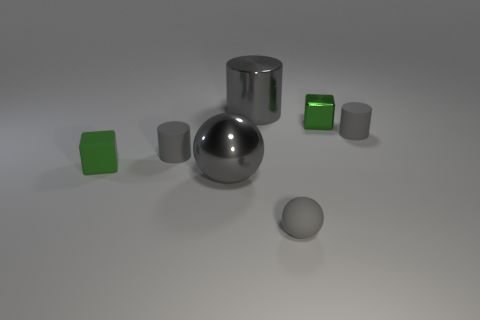How many gray cylinders must be subtracted to get 1 gray cylinders? 2 Subtract all small gray cylinders. How many cylinders are left? 1 Add 2 gray cylinders. How many objects exist? 9 Subtract 1 blocks. How many blocks are left? 1 Subtract all cylinders. How many objects are left? 4 Add 7 big gray objects. How many big gray objects are left? 9 Add 4 small matte blocks. How many small matte blocks exist? 5 Subtract 0 blue cylinders. How many objects are left? 7 Subtract all cyan spheres. Subtract all brown cylinders. How many spheres are left? 2 Subtract all tiny rubber spheres. Subtract all brown shiny cylinders. How many objects are left? 6 